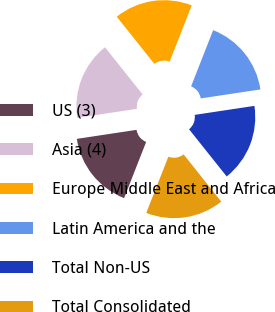<chart> <loc_0><loc_0><loc_500><loc_500><pie_chart><fcel>US (3)<fcel>Asia (4)<fcel>Europe Middle East and Africa<fcel>Latin America and the<fcel>Total Non-US<fcel>Total Consolidated<nl><fcel>16.66%<fcel>16.67%<fcel>16.67%<fcel>16.67%<fcel>16.67%<fcel>16.67%<nl></chart> 